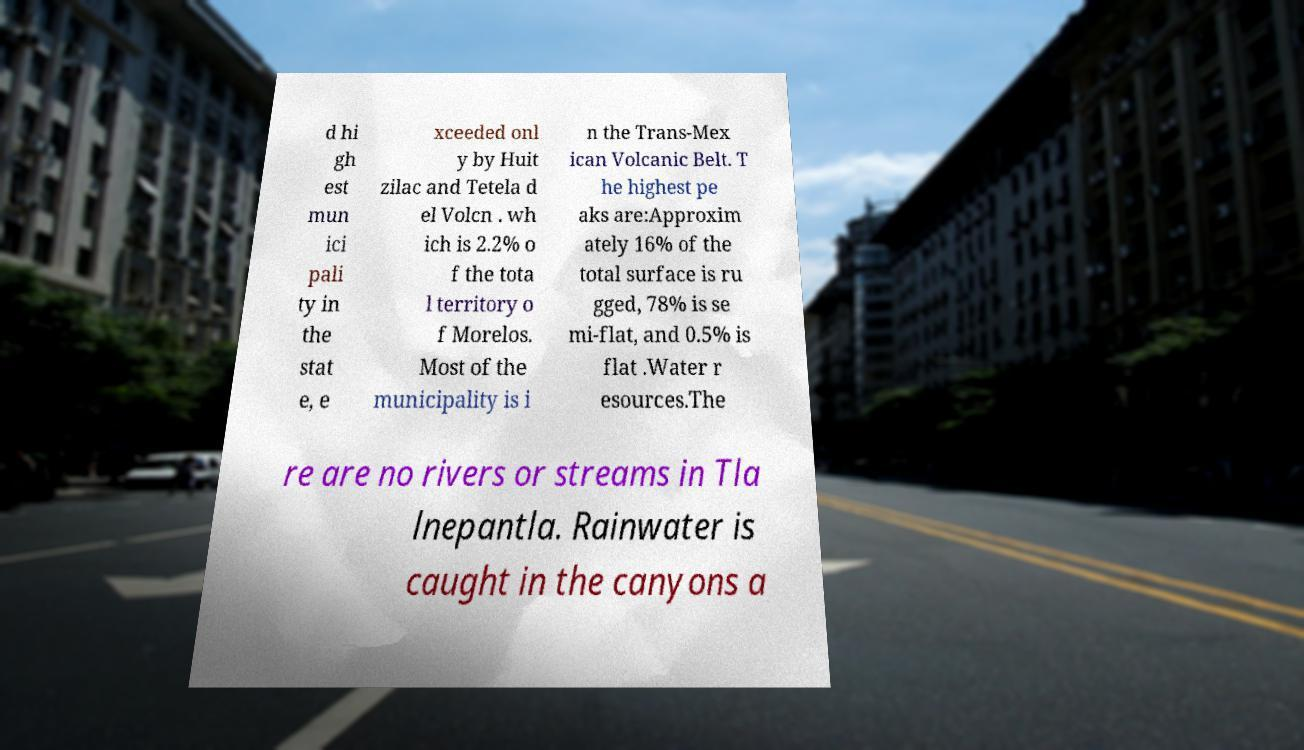There's text embedded in this image that I need extracted. Can you transcribe it verbatim? d hi gh est mun ici pali ty in the stat e, e xceeded onl y by Huit zilac and Tetela d el Volcn . wh ich is 2.2% o f the tota l territory o f Morelos. Most of the municipality is i n the Trans-Mex ican Volcanic Belt. T he highest pe aks are:Approxim ately 16% of the total surface is ru gged, 78% is se mi-flat, and 0.5% is flat .Water r esources.The re are no rivers or streams in Tla lnepantla. Rainwater is caught in the canyons a 